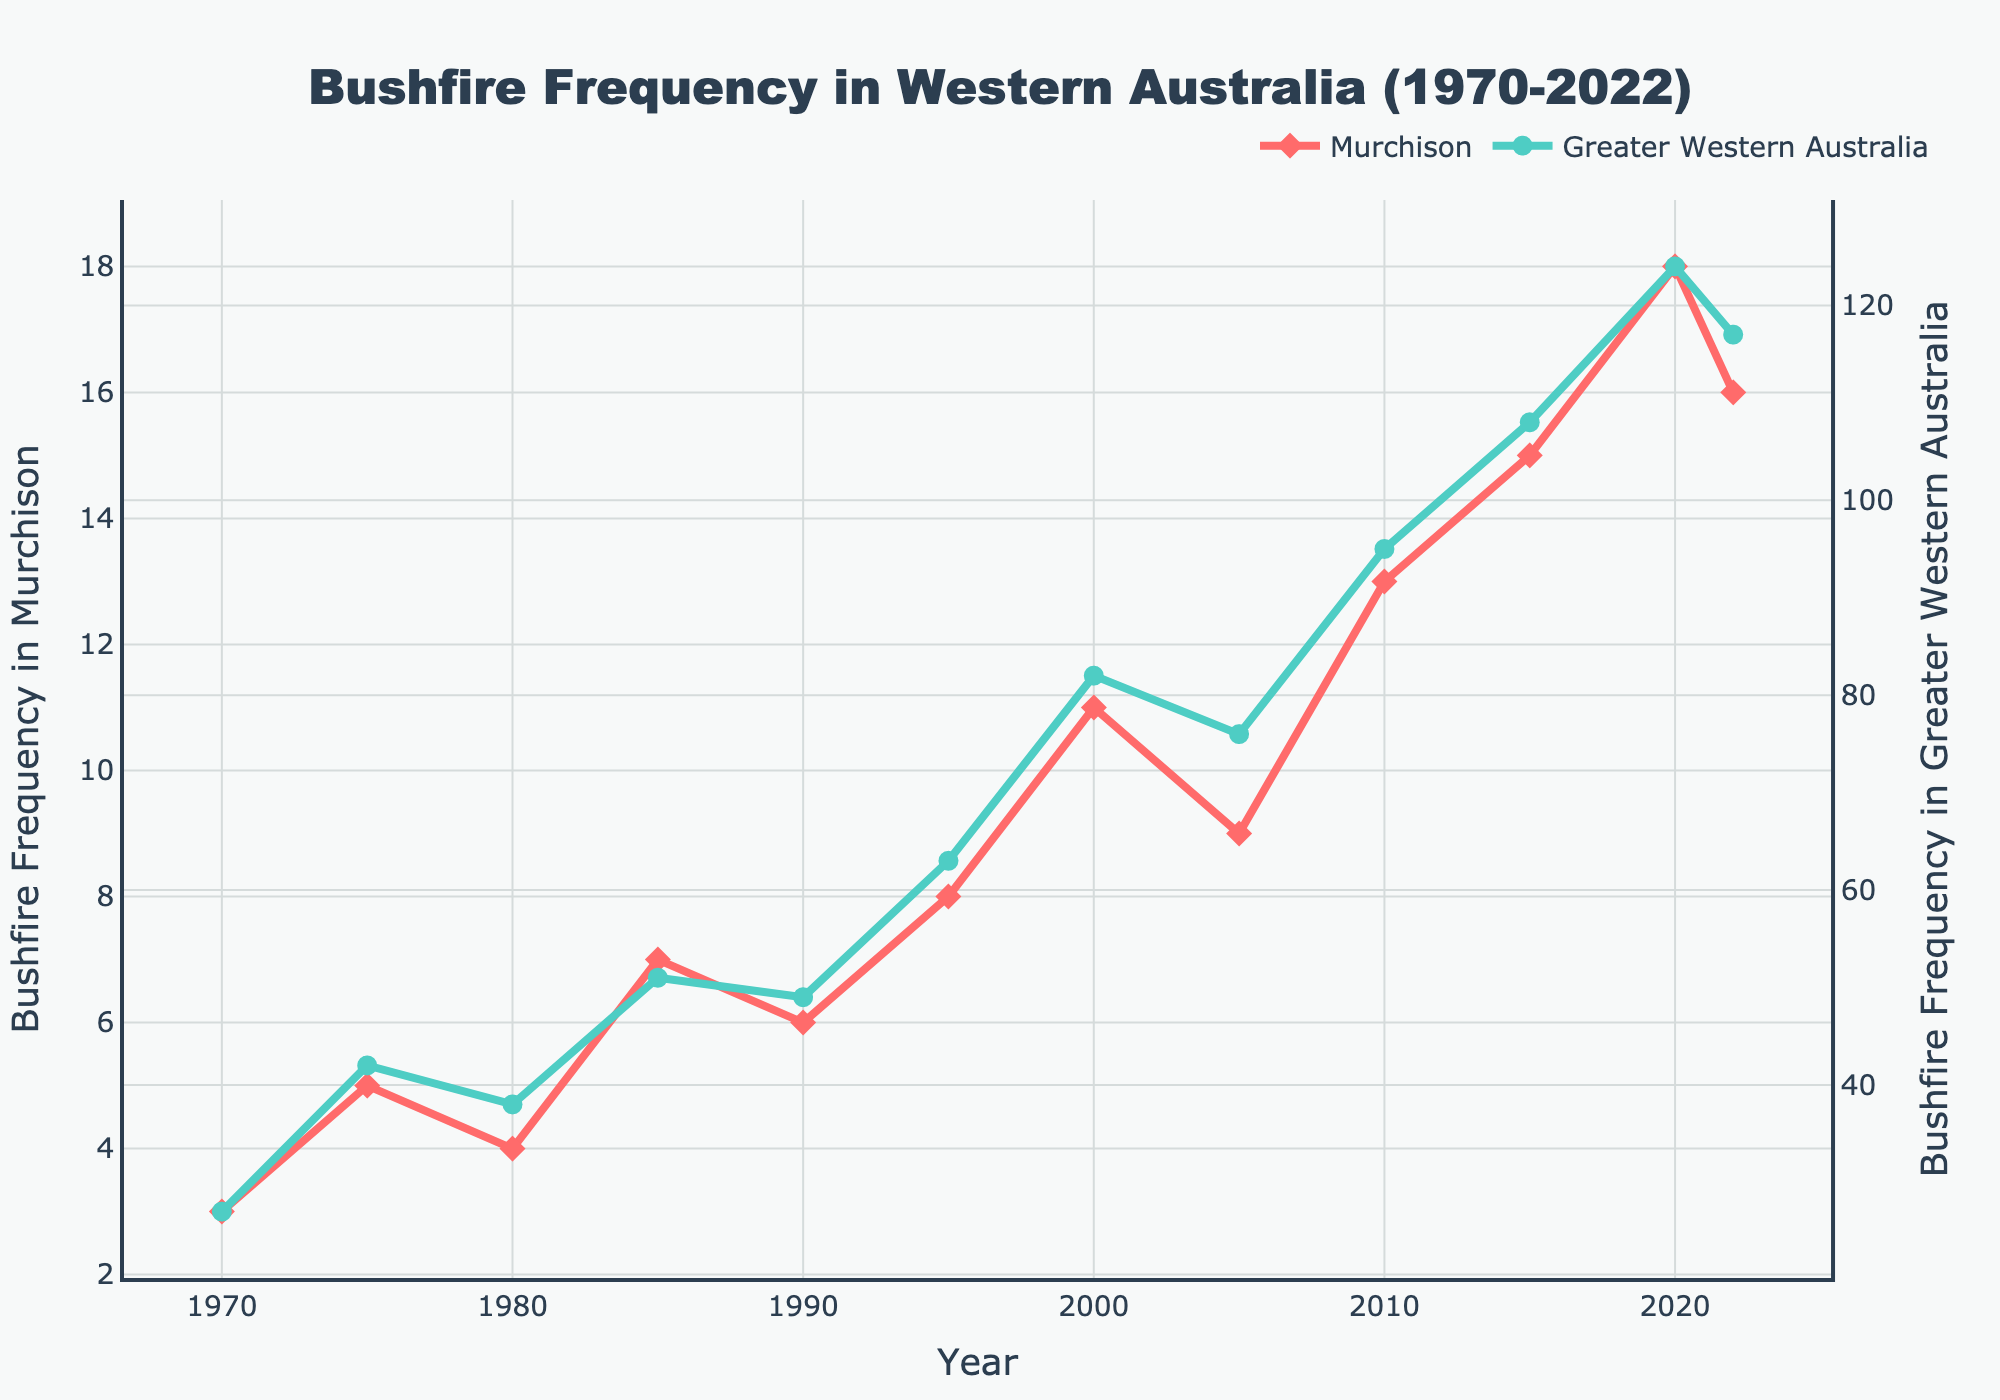What is the overall trend in Murchison's bushfire frequency from 1970 to 2022? The line representing Murchison's bushfire frequency shows an increasing trend from 3 incidents in 1970 to 16 incidents in 2022.
Answer: Increasing In which year did Murchison experience the highest frequency of bushfires? By inspecting the red line on the chart, the highest frequency in Murchison was in 2020 with 18 bushfires.
Answer: 2020 How does the frequency of bushfires in Murchison in 2022 compare to 2010? In 2010, Murchison had 13 bushfires, while in 2022, it had 16. Hence, there were 3 more bushfires in 2022 compared to 2010.
Answer: 3 more What is the difference in the number of bushfires between Murchison and Greater Western Australia in 2020? In 2020, Murchison had 18 bushfires and Greater Western Australia had 124. The difference is 124 - 18 = 106 bushfires.
Answer: 106 Between which consecutive years did Murchison see the largest increase in bushfires? The largest increase can be seen between 2005 (9 bushfires) and 2010 (13 bushfires), which is an increase of 4 bushfires.
Answer: 2005-2010 What is the average frequency of bushfires in Murchison from 1970 to 2022? Sum up the frequencies of bushfires in Murchison from 1970 to 2022: 3+5+4+7+6+8+11+9+13+15+18+16 = 115. The average is 115 / 12 = 9.58.
Answer: 9.58 Compare the trend of bushfire frequency between Murchison and Greater Western Australia. Both lines show an increasing trend over time, but bushfire frequency in Greater Western Australia increases at a faster rate compared to Murchison.
Answer: Faster increase in Greater Western Australia Which area had a higher increase in bushfire frequency from 1985 to 1995: Murchison or Greater Western Australia? For Murchison, 1995 had 8 bushfires and 1985 had 7 bushfires, an increase of 1. For Greater Western Australia, 1995 had 63 bushfires and 1985 had 51 bushfires, an increase of 12.
Answer: Greater Western Australia What is the median frequency of bushfires in Murchison from 1970 to 2022? First, list the frequency values: [3, 4, 5, 6, 7, 8, 9, 11, 13, 15, 16, 18]. The median is the average of the 6th and 7th values: (8 + 9) / 2 = 8.5.
Answer: 8.5 